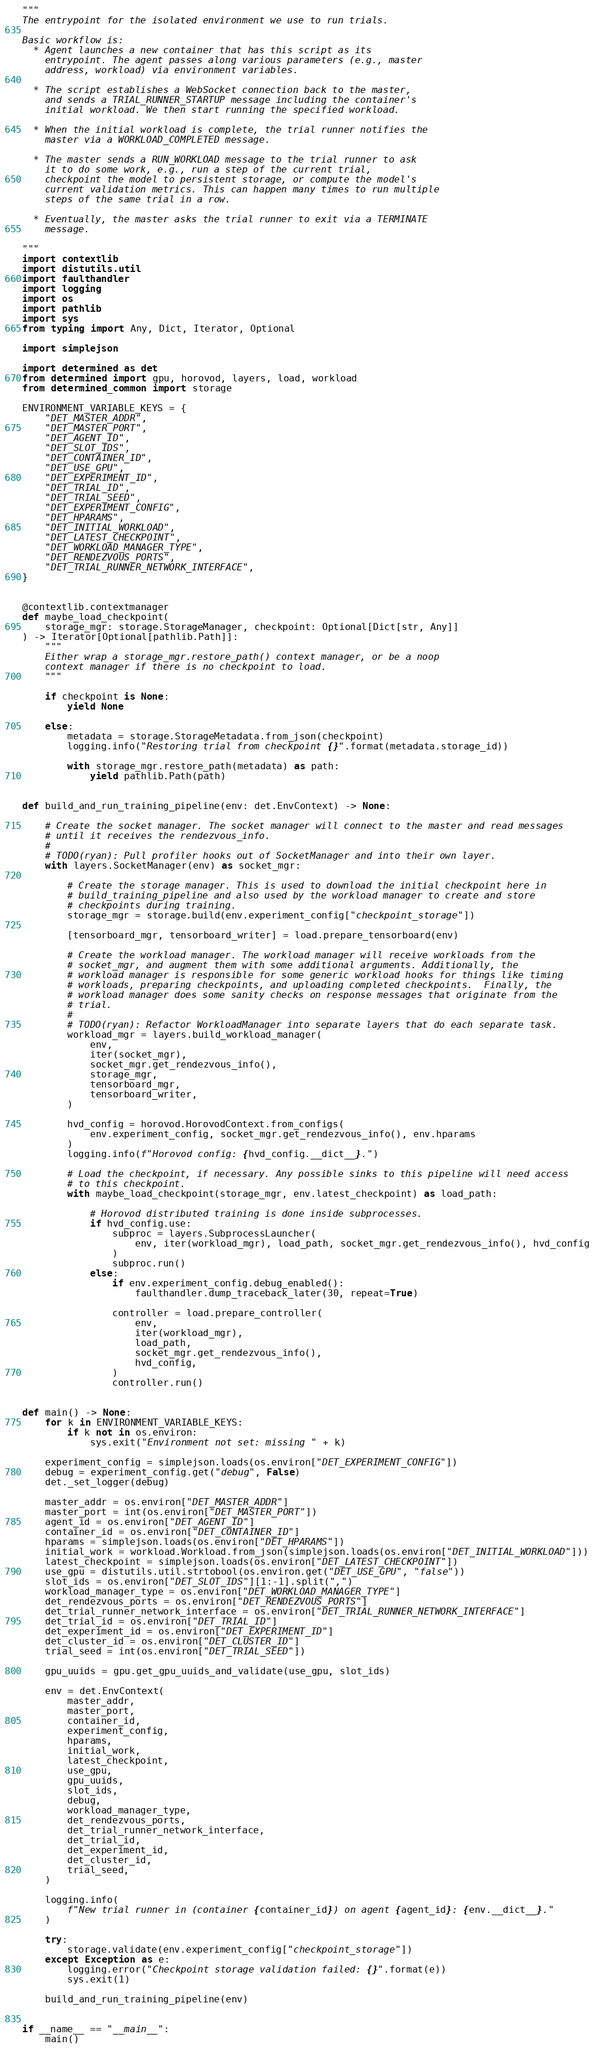Convert code to text. <code><loc_0><loc_0><loc_500><loc_500><_Python_>"""
The entrypoint for the isolated environment we use to run trials.

Basic workflow is:
  * Agent launches a new container that has this script as its
    entrypoint. The agent passes along various parameters (e.g., master
    address, workload) via environment variables.

  * The script establishes a WebSocket connection back to the master,
    and sends a TRIAL_RUNNER_STARTUP message including the container's
    initial workload. We then start running the specified workload.

  * When the initial workload is complete, the trial runner notifies the
    master via a WORKLOAD_COMPLETED message.

  * The master sends a RUN_WORKLOAD message to the trial runner to ask
    it to do some work, e.g., run a step of the current trial,
    checkpoint the model to persistent storage, or compute the model's
    current validation metrics. This can happen many times to run multiple
    steps of the same trial in a row.

  * Eventually, the master asks the trial runner to exit via a TERMINATE
    message.

"""
import contextlib
import distutils.util
import faulthandler
import logging
import os
import pathlib
import sys
from typing import Any, Dict, Iterator, Optional

import simplejson

import determined as det
from determined import gpu, horovod, layers, load, workload
from determined_common import storage

ENVIRONMENT_VARIABLE_KEYS = {
    "DET_MASTER_ADDR",
    "DET_MASTER_PORT",
    "DET_AGENT_ID",
    "DET_SLOT_IDS",
    "DET_CONTAINER_ID",
    "DET_USE_GPU",
    "DET_EXPERIMENT_ID",
    "DET_TRIAL_ID",
    "DET_TRIAL_SEED",
    "DET_EXPERIMENT_CONFIG",
    "DET_HPARAMS",
    "DET_INITIAL_WORKLOAD",
    "DET_LATEST_CHECKPOINT",
    "DET_WORKLOAD_MANAGER_TYPE",
    "DET_RENDEZVOUS_PORTS",
    "DET_TRIAL_RUNNER_NETWORK_INTERFACE",
}


@contextlib.contextmanager
def maybe_load_checkpoint(
    storage_mgr: storage.StorageManager, checkpoint: Optional[Dict[str, Any]]
) -> Iterator[Optional[pathlib.Path]]:
    """
    Either wrap a storage_mgr.restore_path() context manager, or be a noop
    context manager if there is no checkpoint to load.
    """

    if checkpoint is None:
        yield None

    else:
        metadata = storage.StorageMetadata.from_json(checkpoint)
        logging.info("Restoring trial from checkpoint {}".format(metadata.storage_id))

        with storage_mgr.restore_path(metadata) as path:
            yield pathlib.Path(path)


def build_and_run_training_pipeline(env: det.EnvContext) -> None:

    # Create the socket manager. The socket manager will connect to the master and read messages
    # until it receives the rendezvous_info.
    #
    # TODO(ryan): Pull profiler hooks out of SocketManager and into their own layer.
    with layers.SocketManager(env) as socket_mgr:

        # Create the storage manager. This is used to download the initial checkpoint here in
        # build_training_pipeline and also used by the workload manager to create and store
        # checkpoints during training.
        storage_mgr = storage.build(env.experiment_config["checkpoint_storage"])

        [tensorboard_mgr, tensorboard_writer] = load.prepare_tensorboard(env)

        # Create the workload manager. The workload manager will receive workloads from the
        # socket_mgr, and augment them with some additional arguments. Additionally, the
        # workload manager is responsible for some generic workload hooks for things like timing
        # workloads, preparing checkpoints, and uploading completed checkpoints.  Finally, the
        # workload manager does some sanity checks on response messages that originate from the
        # trial.
        #
        # TODO(ryan): Refactor WorkloadManager into separate layers that do each separate task.
        workload_mgr = layers.build_workload_manager(
            env,
            iter(socket_mgr),
            socket_mgr.get_rendezvous_info(),
            storage_mgr,
            tensorboard_mgr,
            tensorboard_writer,
        )

        hvd_config = horovod.HorovodContext.from_configs(
            env.experiment_config, socket_mgr.get_rendezvous_info(), env.hparams
        )
        logging.info(f"Horovod config: {hvd_config.__dict__}.")

        # Load the checkpoint, if necessary. Any possible sinks to this pipeline will need access
        # to this checkpoint.
        with maybe_load_checkpoint(storage_mgr, env.latest_checkpoint) as load_path:

            # Horovod distributed training is done inside subprocesses.
            if hvd_config.use:
                subproc = layers.SubprocessLauncher(
                    env, iter(workload_mgr), load_path, socket_mgr.get_rendezvous_info(), hvd_config
                )
                subproc.run()
            else:
                if env.experiment_config.debug_enabled():
                    faulthandler.dump_traceback_later(30, repeat=True)

                controller = load.prepare_controller(
                    env,
                    iter(workload_mgr),
                    load_path,
                    socket_mgr.get_rendezvous_info(),
                    hvd_config,
                )
                controller.run()


def main() -> None:
    for k in ENVIRONMENT_VARIABLE_KEYS:
        if k not in os.environ:
            sys.exit("Environment not set: missing " + k)

    experiment_config = simplejson.loads(os.environ["DET_EXPERIMENT_CONFIG"])
    debug = experiment_config.get("debug", False)
    det._set_logger(debug)

    master_addr = os.environ["DET_MASTER_ADDR"]
    master_port = int(os.environ["DET_MASTER_PORT"])
    agent_id = os.environ["DET_AGENT_ID"]
    container_id = os.environ["DET_CONTAINER_ID"]
    hparams = simplejson.loads(os.environ["DET_HPARAMS"])
    initial_work = workload.Workload.from_json(simplejson.loads(os.environ["DET_INITIAL_WORKLOAD"]))
    latest_checkpoint = simplejson.loads(os.environ["DET_LATEST_CHECKPOINT"])
    use_gpu = distutils.util.strtobool(os.environ.get("DET_USE_GPU", "false"))
    slot_ids = os.environ["DET_SLOT_IDS"][1:-1].split(",")
    workload_manager_type = os.environ["DET_WORKLOAD_MANAGER_TYPE"]
    det_rendezvous_ports = os.environ["DET_RENDEZVOUS_PORTS"]
    det_trial_runner_network_interface = os.environ["DET_TRIAL_RUNNER_NETWORK_INTERFACE"]
    det_trial_id = os.environ["DET_TRIAL_ID"]
    det_experiment_id = os.environ["DET_EXPERIMENT_ID"]
    det_cluster_id = os.environ["DET_CLUSTER_ID"]
    trial_seed = int(os.environ["DET_TRIAL_SEED"])

    gpu_uuids = gpu.get_gpu_uuids_and_validate(use_gpu, slot_ids)

    env = det.EnvContext(
        master_addr,
        master_port,
        container_id,
        experiment_config,
        hparams,
        initial_work,
        latest_checkpoint,
        use_gpu,
        gpu_uuids,
        slot_ids,
        debug,
        workload_manager_type,
        det_rendezvous_ports,
        det_trial_runner_network_interface,
        det_trial_id,
        det_experiment_id,
        det_cluster_id,
        trial_seed,
    )

    logging.info(
        f"New trial runner in (container {container_id}) on agent {agent_id}: {env.__dict__}."
    )

    try:
        storage.validate(env.experiment_config["checkpoint_storage"])
    except Exception as e:
        logging.error("Checkpoint storage validation failed: {}".format(e))
        sys.exit(1)

    build_and_run_training_pipeline(env)


if __name__ == "__main__":
    main()
</code> 